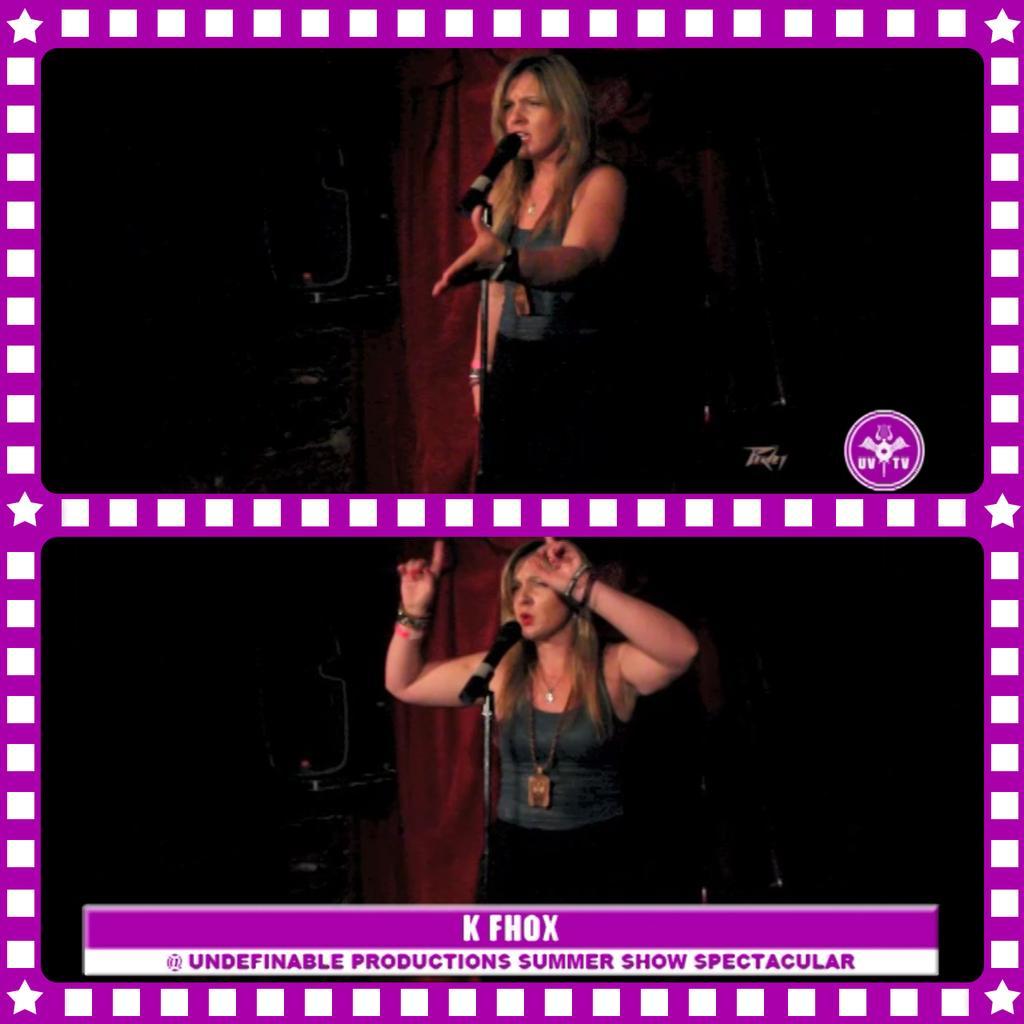Please provide a concise description of this image. This is a collage. On the first image there is a lady standing and in front of her there is a mic with mic stand. Below image same lady is standing and in front of her there is a mic and mic stand. Also there is something written. Also there is a pink border for the image. 